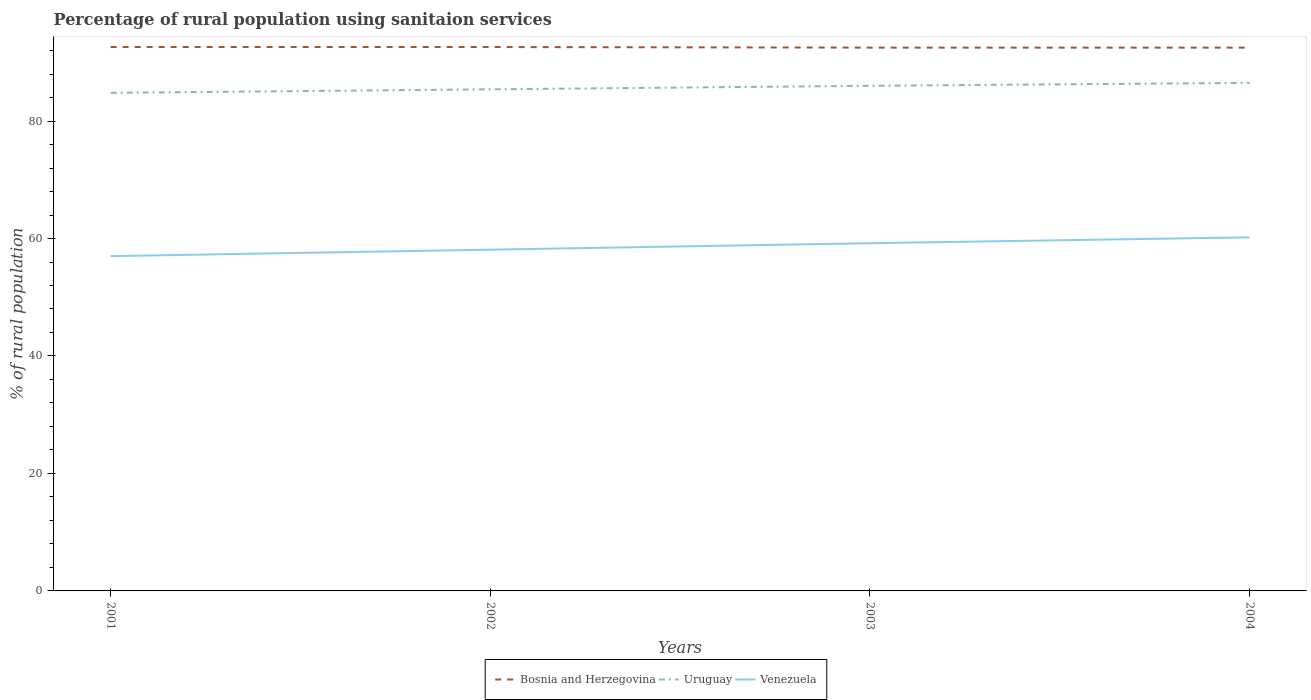Is the number of lines equal to the number of legend labels?
Provide a succinct answer. Yes. Across all years, what is the maximum percentage of rural population using sanitaion services in Uruguay?
Ensure brevity in your answer.  84.8. In which year was the percentage of rural population using sanitaion services in Uruguay maximum?
Ensure brevity in your answer.  2001. What is the total percentage of rural population using sanitaion services in Uruguay in the graph?
Give a very brief answer. -1.7. What is the difference between the highest and the second highest percentage of rural population using sanitaion services in Venezuela?
Provide a short and direct response. 3.2. Is the percentage of rural population using sanitaion services in Uruguay strictly greater than the percentage of rural population using sanitaion services in Venezuela over the years?
Your answer should be compact. No. How many lines are there?
Ensure brevity in your answer.  3. How many years are there in the graph?
Make the answer very short. 4. What is the difference between two consecutive major ticks on the Y-axis?
Give a very brief answer. 20. Does the graph contain any zero values?
Offer a very short reply. No. Does the graph contain grids?
Give a very brief answer. No. How many legend labels are there?
Keep it short and to the point. 3. How are the legend labels stacked?
Offer a terse response. Horizontal. What is the title of the graph?
Keep it short and to the point. Percentage of rural population using sanitaion services. Does "Low income" appear as one of the legend labels in the graph?
Offer a terse response. No. What is the label or title of the Y-axis?
Keep it short and to the point. % of rural population. What is the % of rural population in Bosnia and Herzegovina in 2001?
Your answer should be compact. 92.6. What is the % of rural population in Uruguay in 2001?
Provide a succinct answer. 84.8. What is the % of rural population in Bosnia and Herzegovina in 2002?
Your response must be concise. 92.6. What is the % of rural population in Uruguay in 2002?
Your answer should be very brief. 85.4. What is the % of rural population of Venezuela in 2002?
Give a very brief answer. 58.1. What is the % of rural population of Bosnia and Herzegovina in 2003?
Your answer should be compact. 92.5. What is the % of rural population of Venezuela in 2003?
Your response must be concise. 59.2. What is the % of rural population of Bosnia and Herzegovina in 2004?
Offer a very short reply. 92.5. What is the % of rural population in Uruguay in 2004?
Offer a terse response. 86.5. What is the % of rural population in Venezuela in 2004?
Provide a short and direct response. 60.2. Across all years, what is the maximum % of rural population in Bosnia and Herzegovina?
Your answer should be compact. 92.6. Across all years, what is the maximum % of rural population of Uruguay?
Provide a succinct answer. 86.5. Across all years, what is the maximum % of rural population of Venezuela?
Your answer should be compact. 60.2. Across all years, what is the minimum % of rural population in Bosnia and Herzegovina?
Provide a succinct answer. 92.5. Across all years, what is the minimum % of rural population in Uruguay?
Make the answer very short. 84.8. Across all years, what is the minimum % of rural population of Venezuela?
Offer a terse response. 57. What is the total % of rural population of Bosnia and Herzegovina in the graph?
Give a very brief answer. 370.2. What is the total % of rural population of Uruguay in the graph?
Keep it short and to the point. 342.7. What is the total % of rural population in Venezuela in the graph?
Offer a terse response. 234.5. What is the difference between the % of rural population in Bosnia and Herzegovina in 2001 and that in 2002?
Make the answer very short. 0. What is the difference between the % of rural population of Venezuela in 2001 and that in 2003?
Give a very brief answer. -2.2. What is the difference between the % of rural population in Bosnia and Herzegovina in 2001 and that in 2004?
Provide a succinct answer. 0.1. What is the difference between the % of rural population of Uruguay in 2001 and that in 2004?
Offer a terse response. -1.7. What is the difference between the % of rural population of Venezuela in 2001 and that in 2004?
Give a very brief answer. -3.2. What is the difference between the % of rural population in Uruguay in 2002 and that in 2003?
Offer a terse response. -0.6. What is the difference between the % of rural population of Bosnia and Herzegovina in 2003 and that in 2004?
Your answer should be very brief. 0. What is the difference between the % of rural population of Uruguay in 2003 and that in 2004?
Provide a succinct answer. -0.5. What is the difference between the % of rural population in Bosnia and Herzegovina in 2001 and the % of rural population in Venezuela in 2002?
Your answer should be very brief. 34.5. What is the difference between the % of rural population of Uruguay in 2001 and the % of rural population of Venezuela in 2002?
Your answer should be very brief. 26.7. What is the difference between the % of rural population of Bosnia and Herzegovina in 2001 and the % of rural population of Uruguay in 2003?
Your answer should be very brief. 6.6. What is the difference between the % of rural population of Bosnia and Herzegovina in 2001 and the % of rural population of Venezuela in 2003?
Your answer should be very brief. 33.4. What is the difference between the % of rural population in Uruguay in 2001 and the % of rural population in Venezuela in 2003?
Offer a terse response. 25.6. What is the difference between the % of rural population in Bosnia and Herzegovina in 2001 and the % of rural population in Uruguay in 2004?
Offer a terse response. 6.1. What is the difference between the % of rural population of Bosnia and Herzegovina in 2001 and the % of rural population of Venezuela in 2004?
Your answer should be compact. 32.4. What is the difference between the % of rural population in Uruguay in 2001 and the % of rural population in Venezuela in 2004?
Your answer should be very brief. 24.6. What is the difference between the % of rural population of Bosnia and Herzegovina in 2002 and the % of rural population of Venezuela in 2003?
Offer a very short reply. 33.4. What is the difference between the % of rural population in Uruguay in 2002 and the % of rural population in Venezuela in 2003?
Your response must be concise. 26.2. What is the difference between the % of rural population in Bosnia and Herzegovina in 2002 and the % of rural population in Venezuela in 2004?
Your answer should be very brief. 32.4. What is the difference between the % of rural population in Uruguay in 2002 and the % of rural population in Venezuela in 2004?
Your answer should be very brief. 25.2. What is the difference between the % of rural population in Bosnia and Herzegovina in 2003 and the % of rural population in Venezuela in 2004?
Your answer should be compact. 32.3. What is the difference between the % of rural population in Uruguay in 2003 and the % of rural population in Venezuela in 2004?
Make the answer very short. 25.8. What is the average % of rural population of Bosnia and Herzegovina per year?
Make the answer very short. 92.55. What is the average % of rural population in Uruguay per year?
Give a very brief answer. 85.67. What is the average % of rural population of Venezuela per year?
Give a very brief answer. 58.62. In the year 2001, what is the difference between the % of rural population in Bosnia and Herzegovina and % of rural population in Uruguay?
Keep it short and to the point. 7.8. In the year 2001, what is the difference between the % of rural population of Bosnia and Herzegovina and % of rural population of Venezuela?
Your response must be concise. 35.6. In the year 2001, what is the difference between the % of rural population of Uruguay and % of rural population of Venezuela?
Your answer should be very brief. 27.8. In the year 2002, what is the difference between the % of rural population of Bosnia and Herzegovina and % of rural population of Venezuela?
Keep it short and to the point. 34.5. In the year 2002, what is the difference between the % of rural population in Uruguay and % of rural population in Venezuela?
Keep it short and to the point. 27.3. In the year 2003, what is the difference between the % of rural population in Bosnia and Herzegovina and % of rural population in Venezuela?
Provide a succinct answer. 33.3. In the year 2003, what is the difference between the % of rural population in Uruguay and % of rural population in Venezuela?
Provide a succinct answer. 26.8. In the year 2004, what is the difference between the % of rural population in Bosnia and Herzegovina and % of rural population in Venezuela?
Offer a terse response. 32.3. In the year 2004, what is the difference between the % of rural population of Uruguay and % of rural population of Venezuela?
Provide a short and direct response. 26.3. What is the ratio of the % of rural population of Bosnia and Herzegovina in 2001 to that in 2002?
Keep it short and to the point. 1. What is the ratio of the % of rural population in Uruguay in 2001 to that in 2002?
Keep it short and to the point. 0.99. What is the ratio of the % of rural population in Venezuela in 2001 to that in 2002?
Offer a terse response. 0.98. What is the ratio of the % of rural population of Bosnia and Herzegovina in 2001 to that in 2003?
Your answer should be compact. 1. What is the ratio of the % of rural population in Uruguay in 2001 to that in 2003?
Give a very brief answer. 0.99. What is the ratio of the % of rural population in Venezuela in 2001 to that in 2003?
Offer a very short reply. 0.96. What is the ratio of the % of rural population in Bosnia and Herzegovina in 2001 to that in 2004?
Make the answer very short. 1. What is the ratio of the % of rural population in Uruguay in 2001 to that in 2004?
Keep it short and to the point. 0.98. What is the ratio of the % of rural population of Venezuela in 2001 to that in 2004?
Keep it short and to the point. 0.95. What is the ratio of the % of rural population in Bosnia and Herzegovina in 2002 to that in 2003?
Your answer should be very brief. 1. What is the ratio of the % of rural population of Venezuela in 2002 to that in 2003?
Provide a succinct answer. 0.98. What is the ratio of the % of rural population in Bosnia and Herzegovina in 2002 to that in 2004?
Ensure brevity in your answer.  1. What is the ratio of the % of rural population in Uruguay in 2002 to that in 2004?
Your answer should be compact. 0.99. What is the ratio of the % of rural population of Venezuela in 2002 to that in 2004?
Ensure brevity in your answer.  0.97. What is the ratio of the % of rural population in Uruguay in 2003 to that in 2004?
Your answer should be compact. 0.99. What is the ratio of the % of rural population of Venezuela in 2003 to that in 2004?
Offer a terse response. 0.98. What is the difference between the highest and the second highest % of rural population of Uruguay?
Provide a short and direct response. 0.5. What is the difference between the highest and the second highest % of rural population of Venezuela?
Ensure brevity in your answer.  1. What is the difference between the highest and the lowest % of rural population of Bosnia and Herzegovina?
Make the answer very short. 0.1. What is the difference between the highest and the lowest % of rural population in Uruguay?
Your response must be concise. 1.7. 